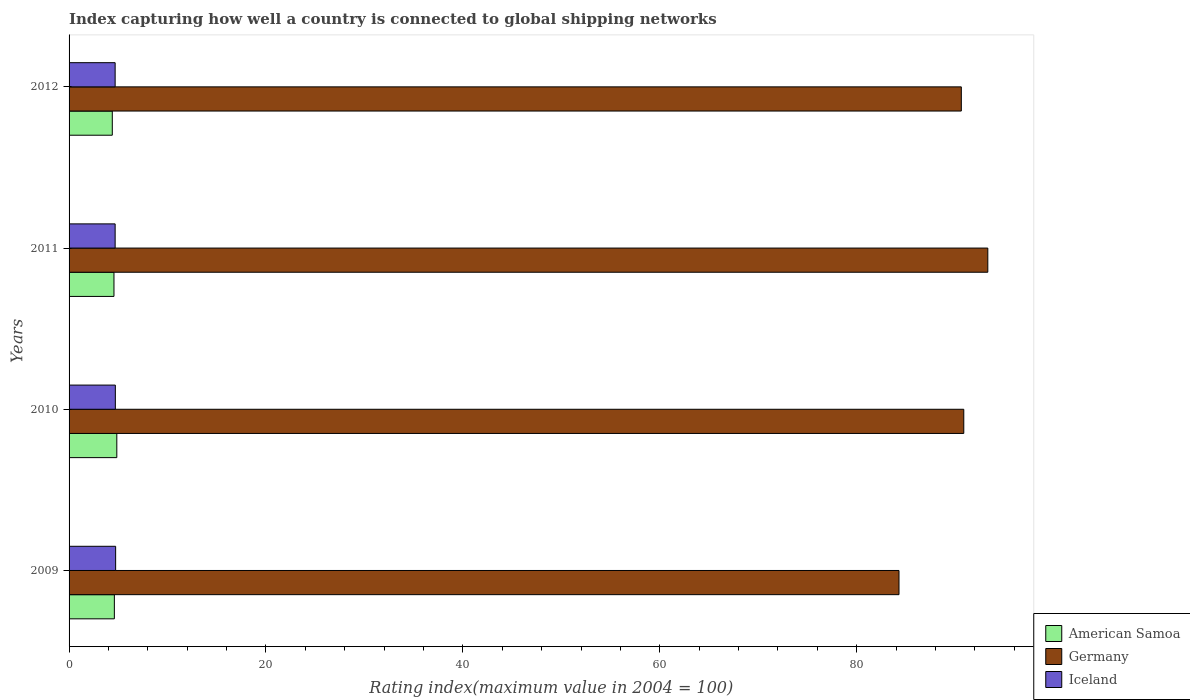How many different coloured bars are there?
Offer a terse response. 3. Are the number of bars per tick equal to the number of legend labels?
Give a very brief answer. Yes. How many bars are there on the 3rd tick from the top?
Your answer should be very brief. 3. How many bars are there on the 3rd tick from the bottom?
Make the answer very short. 3. In how many cases, is the number of bars for a given year not equal to the number of legend labels?
Your response must be concise. 0. What is the rating index in Iceland in 2012?
Your response must be concise. 4.68. Across all years, what is the maximum rating index in Iceland?
Provide a short and direct response. 4.73. Across all years, what is the minimum rating index in Iceland?
Offer a very short reply. 4.68. What is the total rating index in Germany in the graph?
Provide a short and direct response. 359.13. What is the difference between the rating index in Iceland in 2009 and that in 2012?
Your response must be concise. 0.05. What is the difference between the rating index in Germany in 2009 and the rating index in Iceland in 2012?
Make the answer very short. 79.62. What is the average rating index in Iceland per year?
Keep it short and to the point. 4.7. In the year 2010, what is the difference between the rating index in American Samoa and rating index in Germany?
Ensure brevity in your answer.  -86.03. In how many years, is the rating index in American Samoa greater than 84 ?
Make the answer very short. 0. What is the ratio of the rating index in Germany in 2009 to that in 2012?
Offer a terse response. 0.93. Is the rating index in Germany in 2010 less than that in 2012?
Your answer should be compact. No. What is the difference between the highest and the lowest rating index in American Samoa?
Provide a succinct answer. 0.46. In how many years, is the rating index in Germany greater than the average rating index in Germany taken over all years?
Make the answer very short. 3. Is the sum of the rating index in American Samoa in 2010 and 2012 greater than the maximum rating index in Germany across all years?
Your answer should be compact. No. What does the 2nd bar from the top in 2012 represents?
Give a very brief answer. Germany. Is it the case that in every year, the sum of the rating index in Iceland and rating index in Germany is greater than the rating index in American Samoa?
Give a very brief answer. Yes. How many bars are there?
Your answer should be compact. 12. Are all the bars in the graph horizontal?
Your answer should be compact. Yes. How many years are there in the graph?
Offer a terse response. 4. What is the difference between two consecutive major ticks on the X-axis?
Keep it short and to the point. 20. Are the values on the major ticks of X-axis written in scientific E-notation?
Make the answer very short. No. Does the graph contain any zero values?
Keep it short and to the point. No. Does the graph contain grids?
Your answer should be compact. No. How many legend labels are there?
Keep it short and to the point. 3. What is the title of the graph?
Give a very brief answer. Index capturing how well a country is connected to global shipping networks. What is the label or title of the X-axis?
Offer a terse response. Rating index(maximum value in 2004 = 100). What is the Rating index(maximum value in 2004 = 100) in Germany in 2009?
Offer a very short reply. 84.3. What is the Rating index(maximum value in 2004 = 100) in Iceland in 2009?
Ensure brevity in your answer.  4.73. What is the Rating index(maximum value in 2004 = 100) of American Samoa in 2010?
Give a very brief answer. 4.85. What is the Rating index(maximum value in 2004 = 100) in Germany in 2010?
Ensure brevity in your answer.  90.88. What is the Rating index(maximum value in 2004 = 100) in Iceland in 2010?
Provide a succinct answer. 4.7. What is the Rating index(maximum value in 2004 = 100) in American Samoa in 2011?
Provide a short and direct response. 4.56. What is the Rating index(maximum value in 2004 = 100) in Germany in 2011?
Provide a succinct answer. 93.32. What is the Rating index(maximum value in 2004 = 100) of Iceland in 2011?
Offer a very short reply. 4.68. What is the Rating index(maximum value in 2004 = 100) in American Samoa in 2012?
Your answer should be very brief. 4.39. What is the Rating index(maximum value in 2004 = 100) of Germany in 2012?
Ensure brevity in your answer.  90.63. What is the Rating index(maximum value in 2004 = 100) in Iceland in 2012?
Your answer should be compact. 4.68. Across all years, what is the maximum Rating index(maximum value in 2004 = 100) of American Samoa?
Offer a terse response. 4.85. Across all years, what is the maximum Rating index(maximum value in 2004 = 100) of Germany?
Give a very brief answer. 93.32. Across all years, what is the maximum Rating index(maximum value in 2004 = 100) in Iceland?
Your answer should be very brief. 4.73. Across all years, what is the minimum Rating index(maximum value in 2004 = 100) of American Samoa?
Offer a terse response. 4.39. Across all years, what is the minimum Rating index(maximum value in 2004 = 100) in Germany?
Offer a terse response. 84.3. Across all years, what is the minimum Rating index(maximum value in 2004 = 100) of Iceland?
Offer a terse response. 4.68. What is the total Rating index(maximum value in 2004 = 100) of American Samoa in the graph?
Your answer should be very brief. 18.4. What is the total Rating index(maximum value in 2004 = 100) of Germany in the graph?
Provide a short and direct response. 359.13. What is the total Rating index(maximum value in 2004 = 100) in Iceland in the graph?
Provide a succinct answer. 18.79. What is the difference between the Rating index(maximum value in 2004 = 100) of Germany in 2009 and that in 2010?
Provide a succinct answer. -6.58. What is the difference between the Rating index(maximum value in 2004 = 100) in American Samoa in 2009 and that in 2011?
Your answer should be very brief. 0.04. What is the difference between the Rating index(maximum value in 2004 = 100) of Germany in 2009 and that in 2011?
Your answer should be very brief. -9.02. What is the difference between the Rating index(maximum value in 2004 = 100) of Iceland in 2009 and that in 2011?
Provide a succinct answer. 0.05. What is the difference between the Rating index(maximum value in 2004 = 100) in American Samoa in 2009 and that in 2012?
Ensure brevity in your answer.  0.21. What is the difference between the Rating index(maximum value in 2004 = 100) of Germany in 2009 and that in 2012?
Your answer should be very brief. -6.33. What is the difference between the Rating index(maximum value in 2004 = 100) in Iceland in 2009 and that in 2012?
Ensure brevity in your answer.  0.05. What is the difference between the Rating index(maximum value in 2004 = 100) in American Samoa in 2010 and that in 2011?
Offer a terse response. 0.29. What is the difference between the Rating index(maximum value in 2004 = 100) in Germany in 2010 and that in 2011?
Provide a succinct answer. -2.44. What is the difference between the Rating index(maximum value in 2004 = 100) in Iceland in 2010 and that in 2011?
Provide a short and direct response. 0.02. What is the difference between the Rating index(maximum value in 2004 = 100) of American Samoa in 2010 and that in 2012?
Keep it short and to the point. 0.46. What is the difference between the Rating index(maximum value in 2004 = 100) of Iceland in 2010 and that in 2012?
Your answer should be very brief. 0.02. What is the difference between the Rating index(maximum value in 2004 = 100) of American Samoa in 2011 and that in 2012?
Offer a terse response. 0.17. What is the difference between the Rating index(maximum value in 2004 = 100) in Germany in 2011 and that in 2012?
Offer a very short reply. 2.69. What is the difference between the Rating index(maximum value in 2004 = 100) in Iceland in 2011 and that in 2012?
Your answer should be compact. 0. What is the difference between the Rating index(maximum value in 2004 = 100) in American Samoa in 2009 and the Rating index(maximum value in 2004 = 100) in Germany in 2010?
Make the answer very short. -86.28. What is the difference between the Rating index(maximum value in 2004 = 100) in Germany in 2009 and the Rating index(maximum value in 2004 = 100) in Iceland in 2010?
Give a very brief answer. 79.6. What is the difference between the Rating index(maximum value in 2004 = 100) of American Samoa in 2009 and the Rating index(maximum value in 2004 = 100) of Germany in 2011?
Keep it short and to the point. -88.72. What is the difference between the Rating index(maximum value in 2004 = 100) of American Samoa in 2009 and the Rating index(maximum value in 2004 = 100) of Iceland in 2011?
Ensure brevity in your answer.  -0.08. What is the difference between the Rating index(maximum value in 2004 = 100) of Germany in 2009 and the Rating index(maximum value in 2004 = 100) of Iceland in 2011?
Make the answer very short. 79.62. What is the difference between the Rating index(maximum value in 2004 = 100) in American Samoa in 2009 and the Rating index(maximum value in 2004 = 100) in Germany in 2012?
Keep it short and to the point. -86.03. What is the difference between the Rating index(maximum value in 2004 = 100) in American Samoa in 2009 and the Rating index(maximum value in 2004 = 100) in Iceland in 2012?
Keep it short and to the point. -0.08. What is the difference between the Rating index(maximum value in 2004 = 100) in Germany in 2009 and the Rating index(maximum value in 2004 = 100) in Iceland in 2012?
Give a very brief answer. 79.62. What is the difference between the Rating index(maximum value in 2004 = 100) of American Samoa in 2010 and the Rating index(maximum value in 2004 = 100) of Germany in 2011?
Offer a very short reply. -88.47. What is the difference between the Rating index(maximum value in 2004 = 100) in American Samoa in 2010 and the Rating index(maximum value in 2004 = 100) in Iceland in 2011?
Keep it short and to the point. 0.17. What is the difference between the Rating index(maximum value in 2004 = 100) in Germany in 2010 and the Rating index(maximum value in 2004 = 100) in Iceland in 2011?
Make the answer very short. 86.2. What is the difference between the Rating index(maximum value in 2004 = 100) of American Samoa in 2010 and the Rating index(maximum value in 2004 = 100) of Germany in 2012?
Offer a very short reply. -85.78. What is the difference between the Rating index(maximum value in 2004 = 100) in American Samoa in 2010 and the Rating index(maximum value in 2004 = 100) in Iceland in 2012?
Provide a succinct answer. 0.17. What is the difference between the Rating index(maximum value in 2004 = 100) in Germany in 2010 and the Rating index(maximum value in 2004 = 100) in Iceland in 2012?
Offer a very short reply. 86.2. What is the difference between the Rating index(maximum value in 2004 = 100) of American Samoa in 2011 and the Rating index(maximum value in 2004 = 100) of Germany in 2012?
Your answer should be very brief. -86.07. What is the difference between the Rating index(maximum value in 2004 = 100) in American Samoa in 2011 and the Rating index(maximum value in 2004 = 100) in Iceland in 2012?
Provide a short and direct response. -0.12. What is the difference between the Rating index(maximum value in 2004 = 100) of Germany in 2011 and the Rating index(maximum value in 2004 = 100) of Iceland in 2012?
Make the answer very short. 88.64. What is the average Rating index(maximum value in 2004 = 100) in American Samoa per year?
Provide a succinct answer. 4.6. What is the average Rating index(maximum value in 2004 = 100) in Germany per year?
Make the answer very short. 89.78. What is the average Rating index(maximum value in 2004 = 100) of Iceland per year?
Provide a succinct answer. 4.7. In the year 2009, what is the difference between the Rating index(maximum value in 2004 = 100) of American Samoa and Rating index(maximum value in 2004 = 100) of Germany?
Offer a terse response. -79.7. In the year 2009, what is the difference between the Rating index(maximum value in 2004 = 100) in American Samoa and Rating index(maximum value in 2004 = 100) in Iceland?
Your answer should be compact. -0.13. In the year 2009, what is the difference between the Rating index(maximum value in 2004 = 100) in Germany and Rating index(maximum value in 2004 = 100) in Iceland?
Provide a succinct answer. 79.57. In the year 2010, what is the difference between the Rating index(maximum value in 2004 = 100) in American Samoa and Rating index(maximum value in 2004 = 100) in Germany?
Give a very brief answer. -86.03. In the year 2010, what is the difference between the Rating index(maximum value in 2004 = 100) in Germany and Rating index(maximum value in 2004 = 100) in Iceland?
Your answer should be compact. 86.18. In the year 2011, what is the difference between the Rating index(maximum value in 2004 = 100) in American Samoa and Rating index(maximum value in 2004 = 100) in Germany?
Your answer should be compact. -88.76. In the year 2011, what is the difference between the Rating index(maximum value in 2004 = 100) of American Samoa and Rating index(maximum value in 2004 = 100) of Iceland?
Your answer should be compact. -0.12. In the year 2011, what is the difference between the Rating index(maximum value in 2004 = 100) of Germany and Rating index(maximum value in 2004 = 100) of Iceland?
Ensure brevity in your answer.  88.64. In the year 2012, what is the difference between the Rating index(maximum value in 2004 = 100) in American Samoa and Rating index(maximum value in 2004 = 100) in Germany?
Provide a short and direct response. -86.24. In the year 2012, what is the difference between the Rating index(maximum value in 2004 = 100) in American Samoa and Rating index(maximum value in 2004 = 100) in Iceland?
Keep it short and to the point. -0.29. In the year 2012, what is the difference between the Rating index(maximum value in 2004 = 100) in Germany and Rating index(maximum value in 2004 = 100) in Iceland?
Provide a succinct answer. 85.95. What is the ratio of the Rating index(maximum value in 2004 = 100) of American Samoa in 2009 to that in 2010?
Your response must be concise. 0.95. What is the ratio of the Rating index(maximum value in 2004 = 100) of Germany in 2009 to that in 2010?
Your response must be concise. 0.93. What is the ratio of the Rating index(maximum value in 2004 = 100) in Iceland in 2009 to that in 2010?
Make the answer very short. 1.01. What is the ratio of the Rating index(maximum value in 2004 = 100) of American Samoa in 2009 to that in 2011?
Keep it short and to the point. 1.01. What is the ratio of the Rating index(maximum value in 2004 = 100) in Germany in 2009 to that in 2011?
Give a very brief answer. 0.9. What is the ratio of the Rating index(maximum value in 2004 = 100) of Iceland in 2009 to that in 2011?
Keep it short and to the point. 1.01. What is the ratio of the Rating index(maximum value in 2004 = 100) in American Samoa in 2009 to that in 2012?
Give a very brief answer. 1.05. What is the ratio of the Rating index(maximum value in 2004 = 100) of Germany in 2009 to that in 2012?
Make the answer very short. 0.93. What is the ratio of the Rating index(maximum value in 2004 = 100) in Iceland in 2009 to that in 2012?
Give a very brief answer. 1.01. What is the ratio of the Rating index(maximum value in 2004 = 100) of American Samoa in 2010 to that in 2011?
Keep it short and to the point. 1.06. What is the ratio of the Rating index(maximum value in 2004 = 100) in Germany in 2010 to that in 2011?
Give a very brief answer. 0.97. What is the ratio of the Rating index(maximum value in 2004 = 100) of American Samoa in 2010 to that in 2012?
Keep it short and to the point. 1.1. What is the ratio of the Rating index(maximum value in 2004 = 100) of Iceland in 2010 to that in 2012?
Your answer should be very brief. 1. What is the ratio of the Rating index(maximum value in 2004 = 100) of American Samoa in 2011 to that in 2012?
Make the answer very short. 1.04. What is the ratio of the Rating index(maximum value in 2004 = 100) in Germany in 2011 to that in 2012?
Keep it short and to the point. 1.03. What is the difference between the highest and the second highest Rating index(maximum value in 2004 = 100) of Germany?
Keep it short and to the point. 2.44. What is the difference between the highest and the lowest Rating index(maximum value in 2004 = 100) in American Samoa?
Offer a very short reply. 0.46. What is the difference between the highest and the lowest Rating index(maximum value in 2004 = 100) in Germany?
Provide a short and direct response. 9.02. What is the difference between the highest and the lowest Rating index(maximum value in 2004 = 100) in Iceland?
Provide a succinct answer. 0.05. 